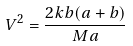<formula> <loc_0><loc_0><loc_500><loc_500>V ^ { 2 } = \frac { 2 k b ( a + b ) } { M a }</formula> 